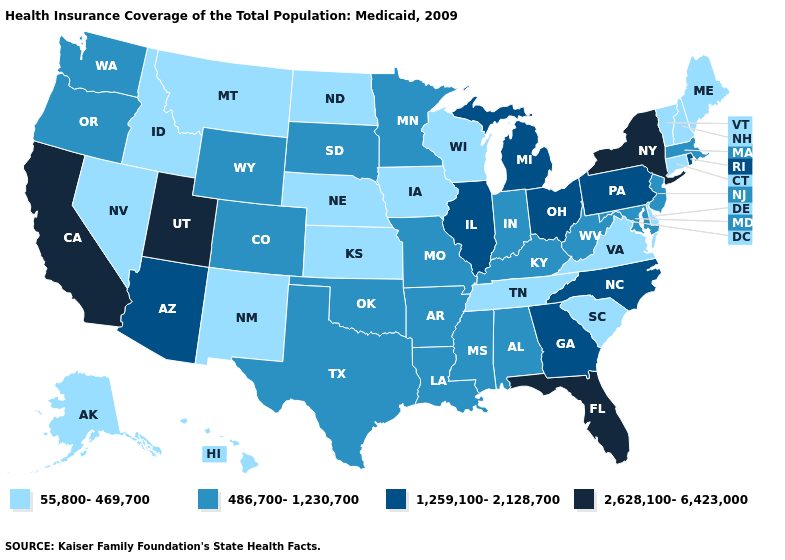Does Mississippi have the highest value in the USA?
Be succinct. No. Among the states that border Alabama , does Georgia have the highest value?
Be succinct. No. What is the highest value in the USA?
Keep it brief. 2,628,100-6,423,000. Does Kentucky have the same value as Kansas?
Quick response, please. No. Which states hav the highest value in the South?
Write a very short answer. Florida. How many symbols are there in the legend?
Concise answer only. 4. What is the highest value in states that border Nebraska?
Answer briefly. 486,700-1,230,700. Does Arizona have the highest value in the USA?
Keep it brief. No. Name the states that have a value in the range 2,628,100-6,423,000?
Answer briefly. California, Florida, New York, Utah. Name the states that have a value in the range 55,800-469,700?
Give a very brief answer. Alaska, Connecticut, Delaware, Hawaii, Idaho, Iowa, Kansas, Maine, Montana, Nebraska, Nevada, New Hampshire, New Mexico, North Dakota, South Carolina, Tennessee, Vermont, Virginia, Wisconsin. Among the states that border West Virginia , does Virginia have the lowest value?
Short answer required. Yes. Does Georgia have the same value as Ohio?
Be succinct. Yes. Which states hav the highest value in the MidWest?
Be succinct. Illinois, Michigan, Ohio. What is the value of Rhode Island?
Keep it brief. 1,259,100-2,128,700. Does Utah have the highest value in the USA?
Short answer required. Yes. 